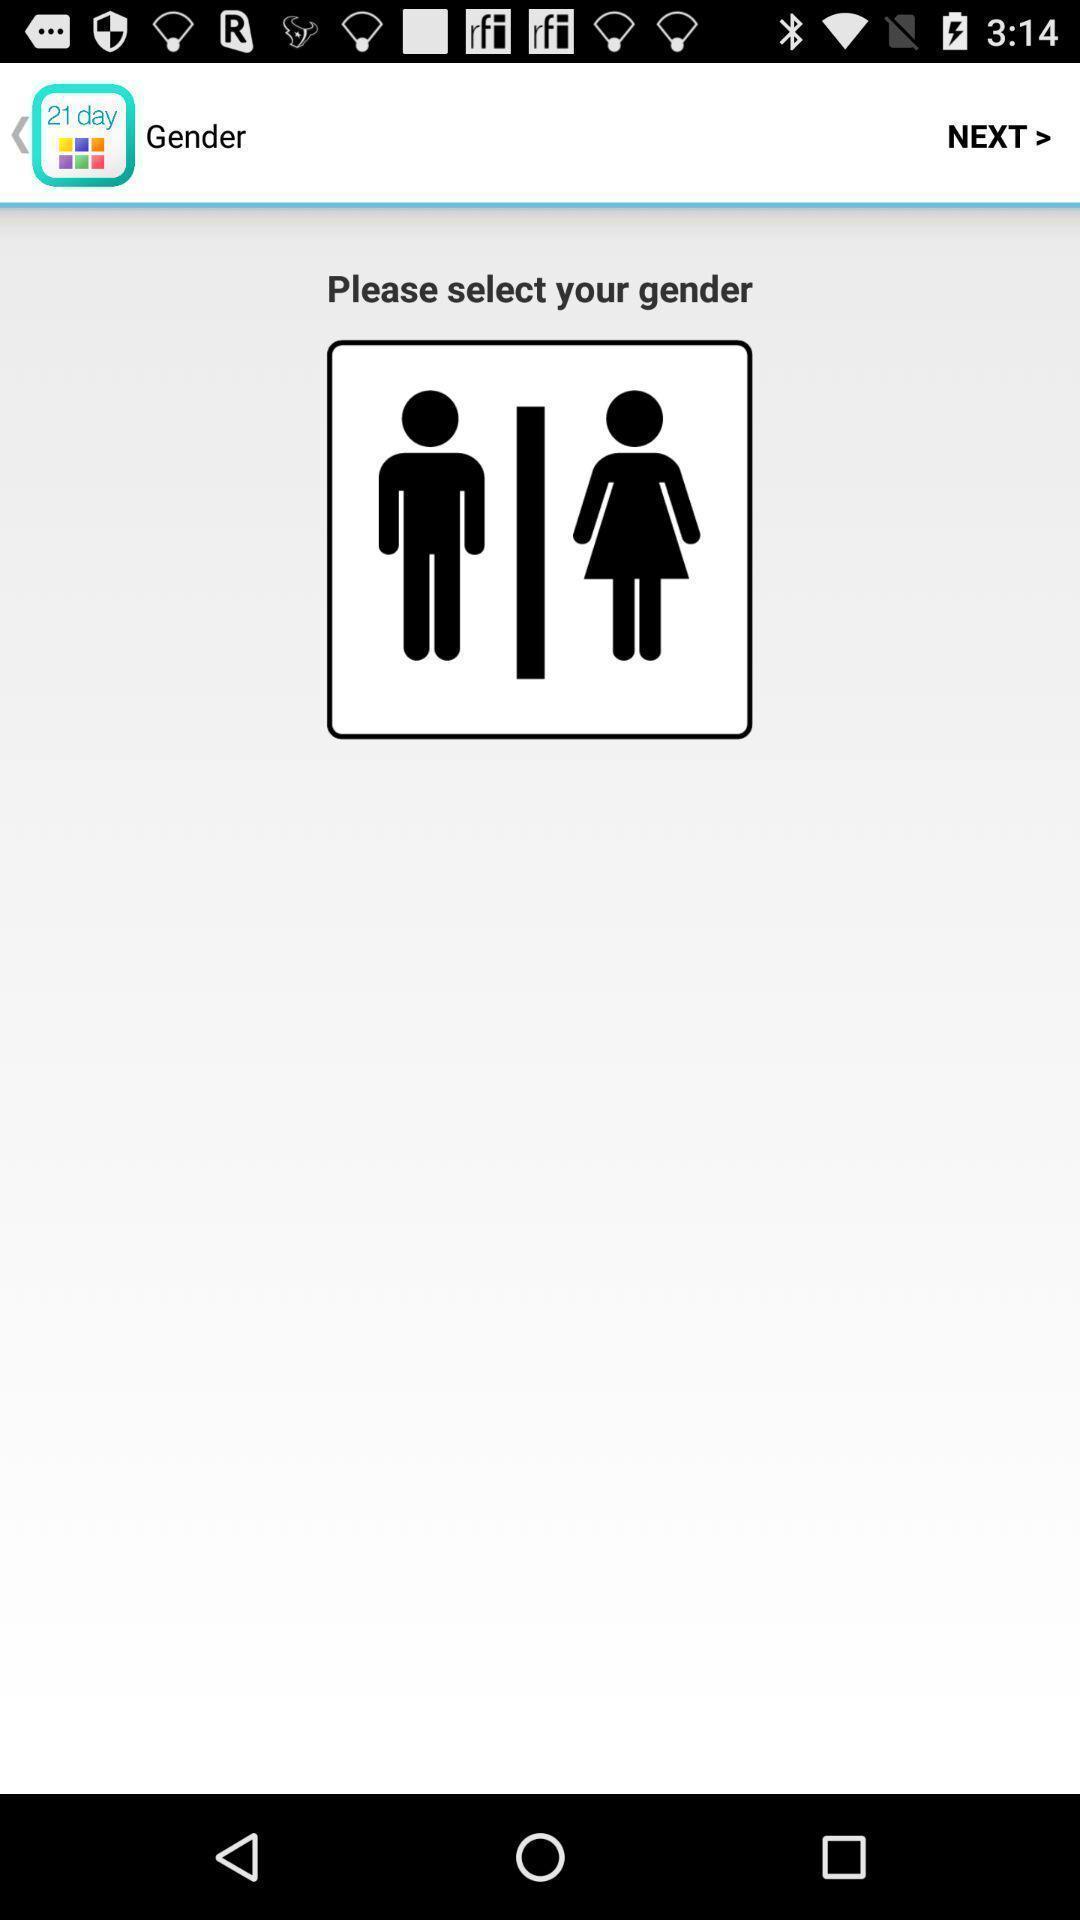Provide a description of this screenshot. Page displaying to select gender. 